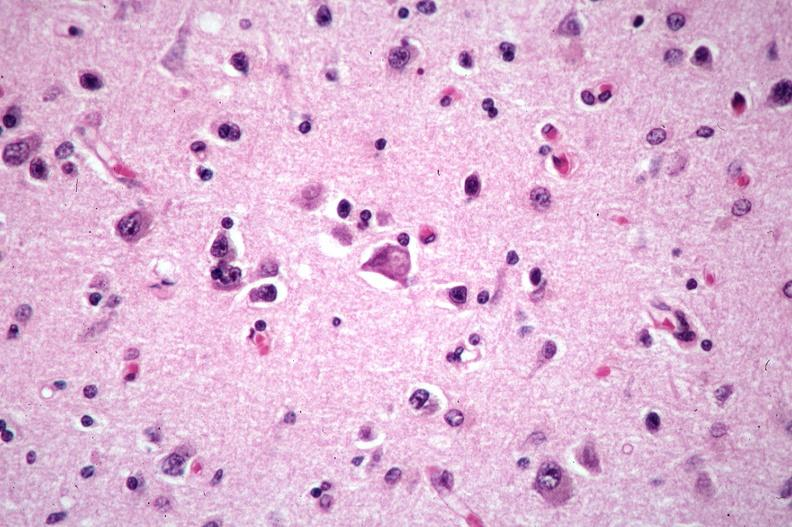what does this image show?
Answer the question using a single word or phrase. Brain 